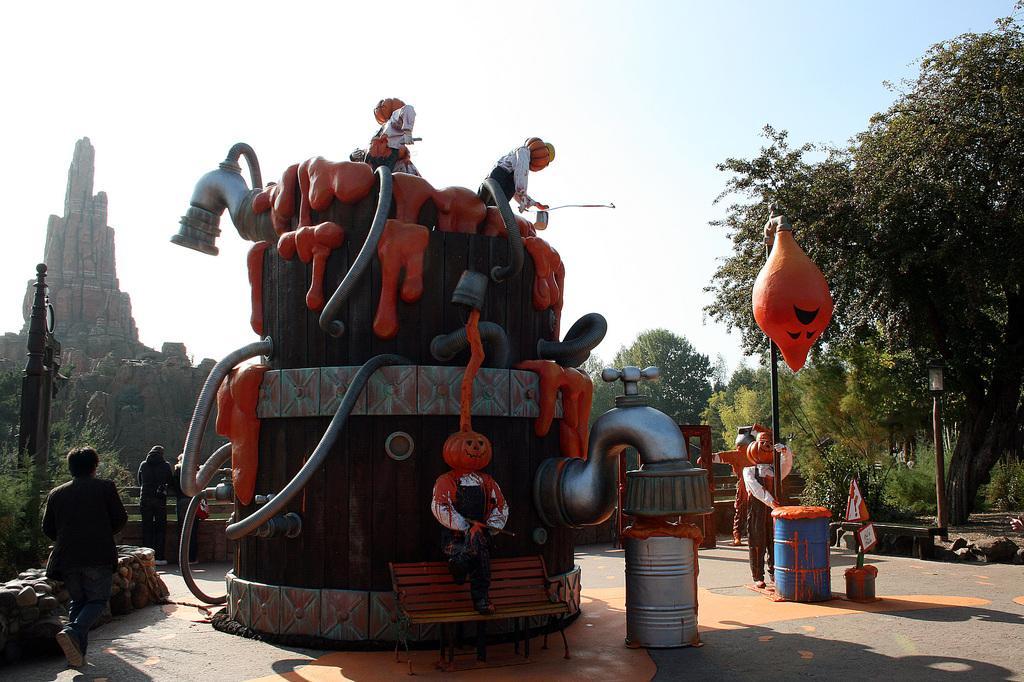Describe this image in one or two sentences. In the center of the image there is a structure on which there are depictions of persons. There are people standing. There are drums. To the right side of the image there are trees. In the background of the image there is a mountain, sky. At the bottom of the image there is floor. 